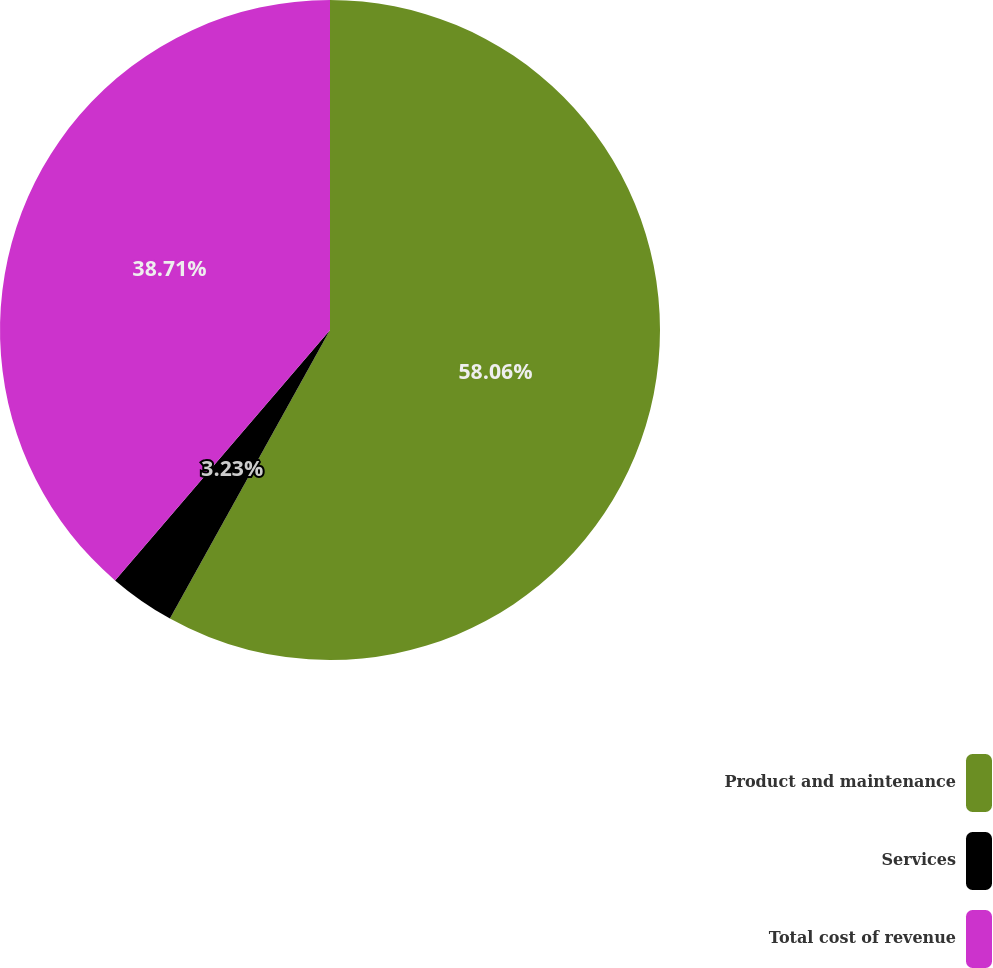Convert chart to OTSL. <chart><loc_0><loc_0><loc_500><loc_500><pie_chart><fcel>Product and maintenance<fcel>Services<fcel>Total cost of revenue<nl><fcel>58.06%<fcel>3.23%<fcel>38.71%<nl></chart> 